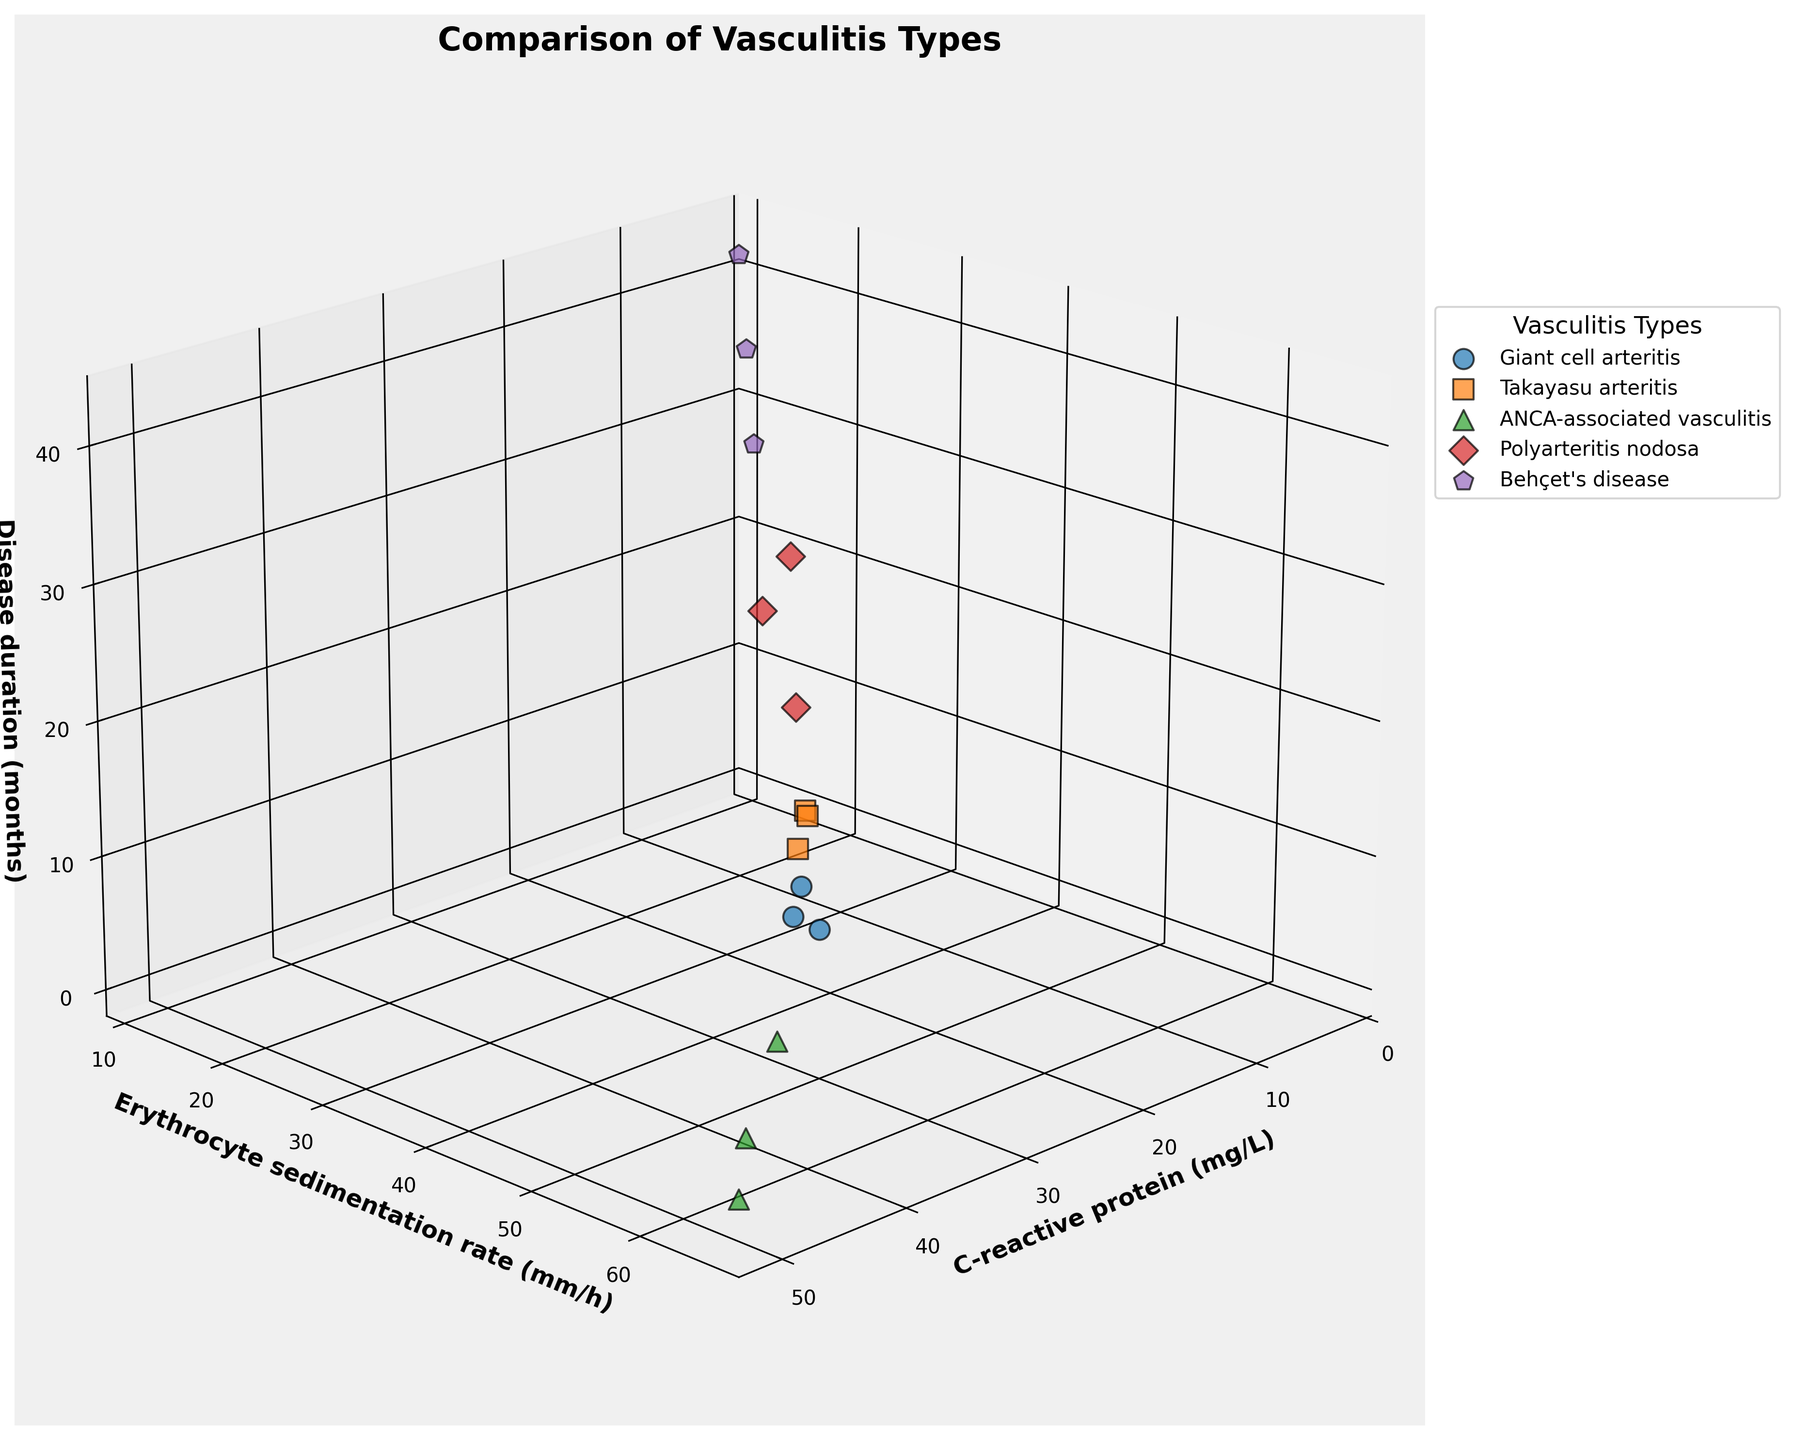What is the title of the figure? The title is located at the top of the figure and provides an overview of what the plot is about.
Answer: Comparison of Vasculitis Types Which vasculitis type is represented by circles in the figure? By referring to the legend and matching the shape of the scatter points, we can see that circles represent "Giant cell arteritis".
Answer: Giant cell arteritis How many data points are shown for ANCA-associated vasculitis? By counting the markers shaped as triangles (as specified for ANCA-associated vasculitis in the legend), we identify there are three such data points.
Answer: 3 What are the axis labels of the figure? Observing the labels on each axis, we can see that the x-axis is labeled "C-reactive protein (mg/L)", the y-axis is labeled "Erythrocyte sedimentation rate (mm/h)" and the z-axis is labeled "Disease duration (months)".
Answer: C-reactive protein (mg/L), Erythrocyte sedimentation rate (mm/h), Disease duration (months) Which vasculitis type has the highest value for C-reactive protein? By examining the scatter points along the x-axis, we see that the highest value for C-reactive protein corresponds to the green triangle, representing ANCA-associated vasculitis.
Answer: ANCA-associated vasculitis Which vasculitis type has the longest disease duration? Looking along the z-axis for the highest value, it corresponds to the purple pentagon marker, which represents Behçet's disease.
Answer: Behçet's disease What is the average C-reactive protein level for Takayasu arteritis? The C-reactive protein levels for Takayasu arteritis are 12, 22, and 15. Summing these values gives 49. Dividing by 3 data points results in an average of 16.33.
Answer: 16.33 Which vasculitis type shows a trend of increasing disease duration with decreasing C-reactive protein? By observing the plotted points, Behçet's disease (represented by purple pentagons) shows an increasing trend in disease duration as C-reactive protein decreases.
Answer: Behçet's disease Which vasculitis type has both high C-reactive protein and a high erythrocyte sedimentation rate? By identifying points with high values on both the x-axis and y-axis, the green triangles (ANCA-associated vasculitis) meet this criterion.
Answer: ANCA-associated vasculitis Which two vasculitis types exhibit overlapping ranges of disease duration? Examining the z-axis spread, both Takayasu arteritis (orange squares) and Giant cell arteritis (blue circles) have overlapping ranges between approximately 3 to 12 months.
Answer: Takayasu arteritis and Giant cell arteritis 